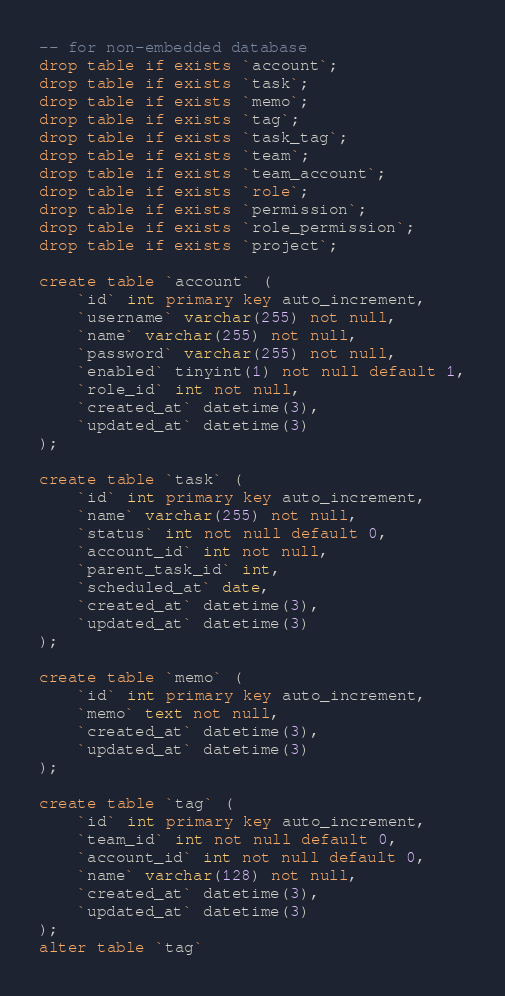Convert code to text. <code><loc_0><loc_0><loc_500><loc_500><_SQL_>-- for non-embedded database
drop table if exists `account`;
drop table if exists `task`;
drop table if exists `memo`;
drop table if exists `tag`;
drop table if exists `task_tag`;
drop table if exists `team`;
drop table if exists `team_account`;
drop table if exists `role`;
drop table if exists `permission`;
drop table if exists `role_permission`;
drop table if exists `project`;

create table `account` (
    `id` int primary key auto_increment,
    `username` varchar(255) not null,
    `name` varchar(255) not null,
    `password` varchar(255) not null,
    `enabled` tinyint(1) not null default 1,
    `role_id` int not null,
    `created_at` datetime(3),
    `updated_at` datetime(3)
);

create table `task` (
    `id` int primary key auto_increment,
    `name` varchar(255) not null,
    `status` int not null default 0,
    `account_id` int not null,
    `parent_task_id` int,
    `scheduled_at` date,
    `created_at` datetime(3),
    `updated_at` datetime(3)
);

create table `memo` (
    `id` int primary key auto_increment,
    `memo` text not null,
    `created_at` datetime(3),
    `updated_at` datetime(3)
);

create table `tag` (
    `id` int primary key auto_increment,
    `team_id` int not null default 0,
    `account_id` int not null default 0,
    `name` varchar(128) not null,
    `created_at` datetime(3),
    `updated_at` datetime(3)
);
alter table `tag`</code> 